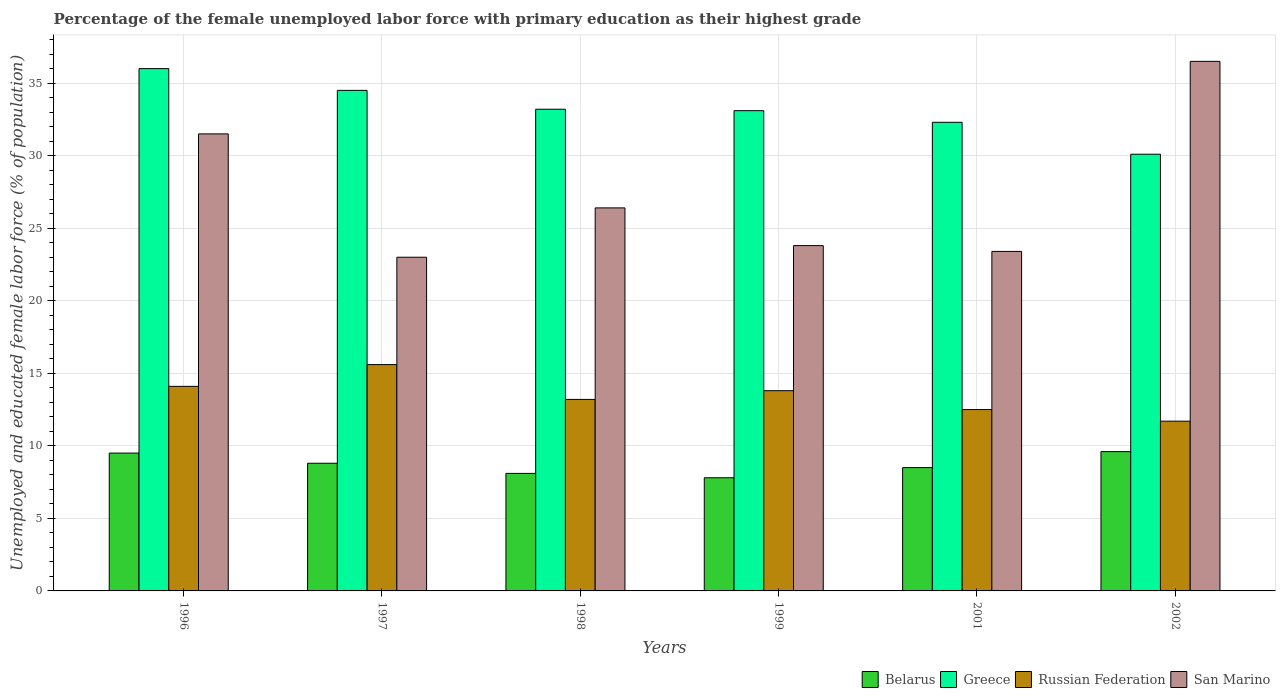How many different coloured bars are there?
Your response must be concise. 4. Are the number of bars per tick equal to the number of legend labels?
Make the answer very short. Yes. How many bars are there on the 3rd tick from the right?
Ensure brevity in your answer.  4. What is the label of the 5th group of bars from the left?
Offer a terse response. 2001. In how many cases, is the number of bars for a given year not equal to the number of legend labels?
Give a very brief answer. 0. What is the percentage of the unemployed female labor force with primary education in San Marino in 2002?
Make the answer very short. 36.5. Across all years, what is the maximum percentage of the unemployed female labor force with primary education in Belarus?
Provide a short and direct response. 9.6. Across all years, what is the minimum percentage of the unemployed female labor force with primary education in Belarus?
Keep it short and to the point. 7.8. In which year was the percentage of the unemployed female labor force with primary education in Greece minimum?
Make the answer very short. 2002. What is the total percentage of the unemployed female labor force with primary education in Russian Federation in the graph?
Your answer should be very brief. 80.9. What is the difference between the percentage of the unemployed female labor force with primary education in Greece in 1996 and that in 1998?
Your answer should be compact. 2.8. What is the difference between the percentage of the unemployed female labor force with primary education in Russian Federation in 2002 and the percentage of the unemployed female labor force with primary education in Belarus in 1996?
Offer a very short reply. 2.2. What is the average percentage of the unemployed female labor force with primary education in Russian Federation per year?
Give a very brief answer. 13.48. In the year 2002, what is the difference between the percentage of the unemployed female labor force with primary education in Russian Federation and percentage of the unemployed female labor force with primary education in Greece?
Provide a succinct answer. -18.4. What is the ratio of the percentage of the unemployed female labor force with primary education in Russian Federation in 1997 to that in 2002?
Your answer should be compact. 1.33. Is the percentage of the unemployed female labor force with primary education in Russian Federation in 1996 less than that in 1998?
Give a very brief answer. No. Is the difference between the percentage of the unemployed female labor force with primary education in Russian Federation in 1999 and 2001 greater than the difference between the percentage of the unemployed female labor force with primary education in Greece in 1999 and 2001?
Provide a short and direct response. Yes. What is the difference between the highest and the second highest percentage of the unemployed female labor force with primary education in Greece?
Make the answer very short. 1.5. What is the difference between the highest and the lowest percentage of the unemployed female labor force with primary education in San Marino?
Your response must be concise. 13.5. What does the 3rd bar from the left in 1999 represents?
Your answer should be compact. Russian Federation. What does the 1st bar from the right in 2002 represents?
Give a very brief answer. San Marino. Is it the case that in every year, the sum of the percentage of the unemployed female labor force with primary education in San Marino and percentage of the unemployed female labor force with primary education in Belarus is greater than the percentage of the unemployed female labor force with primary education in Greece?
Offer a very short reply. No. How many bars are there?
Your answer should be compact. 24. What is the difference between two consecutive major ticks on the Y-axis?
Your answer should be very brief. 5. Does the graph contain any zero values?
Offer a very short reply. No. Does the graph contain grids?
Keep it short and to the point. Yes. How many legend labels are there?
Offer a very short reply. 4. How are the legend labels stacked?
Your answer should be compact. Horizontal. What is the title of the graph?
Give a very brief answer. Percentage of the female unemployed labor force with primary education as their highest grade. What is the label or title of the X-axis?
Make the answer very short. Years. What is the label or title of the Y-axis?
Your answer should be compact. Unemployed and educated female labor force (% of population). What is the Unemployed and educated female labor force (% of population) in Russian Federation in 1996?
Give a very brief answer. 14.1. What is the Unemployed and educated female labor force (% of population) in San Marino in 1996?
Offer a terse response. 31.5. What is the Unemployed and educated female labor force (% of population) in Belarus in 1997?
Provide a succinct answer. 8.8. What is the Unemployed and educated female labor force (% of population) in Greece in 1997?
Your answer should be compact. 34.5. What is the Unemployed and educated female labor force (% of population) in Russian Federation in 1997?
Your response must be concise. 15.6. What is the Unemployed and educated female labor force (% of population) in Belarus in 1998?
Offer a terse response. 8.1. What is the Unemployed and educated female labor force (% of population) of Greece in 1998?
Offer a very short reply. 33.2. What is the Unemployed and educated female labor force (% of population) of Russian Federation in 1998?
Offer a very short reply. 13.2. What is the Unemployed and educated female labor force (% of population) in San Marino in 1998?
Ensure brevity in your answer.  26.4. What is the Unemployed and educated female labor force (% of population) of Belarus in 1999?
Offer a terse response. 7.8. What is the Unemployed and educated female labor force (% of population) in Greece in 1999?
Give a very brief answer. 33.1. What is the Unemployed and educated female labor force (% of population) in Russian Federation in 1999?
Your answer should be compact. 13.8. What is the Unemployed and educated female labor force (% of population) in San Marino in 1999?
Your answer should be compact. 23.8. What is the Unemployed and educated female labor force (% of population) in Greece in 2001?
Keep it short and to the point. 32.3. What is the Unemployed and educated female labor force (% of population) in San Marino in 2001?
Your answer should be very brief. 23.4. What is the Unemployed and educated female labor force (% of population) of Belarus in 2002?
Provide a succinct answer. 9.6. What is the Unemployed and educated female labor force (% of population) of Greece in 2002?
Make the answer very short. 30.1. What is the Unemployed and educated female labor force (% of population) in Russian Federation in 2002?
Keep it short and to the point. 11.7. What is the Unemployed and educated female labor force (% of population) in San Marino in 2002?
Your response must be concise. 36.5. Across all years, what is the maximum Unemployed and educated female labor force (% of population) of Belarus?
Keep it short and to the point. 9.6. Across all years, what is the maximum Unemployed and educated female labor force (% of population) in Greece?
Provide a short and direct response. 36. Across all years, what is the maximum Unemployed and educated female labor force (% of population) of Russian Federation?
Your answer should be compact. 15.6. Across all years, what is the maximum Unemployed and educated female labor force (% of population) in San Marino?
Offer a very short reply. 36.5. Across all years, what is the minimum Unemployed and educated female labor force (% of population) in Belarus?
Your response must be concise. 7.8. Across all years, what is the minimum Unemployed and educated female labor force (% of population) in Greece?
Provide a succinct answer. 30.1. Across all years, what is the minimum Unemployed and educated female labor force (% of population) of Russian Federation?
Make the answer very short. 11.7. What is the total Unemployed and educated female labor force (% of population) of Belarus in the graph?
Provide a short and direct response. 52.3. What is the total Unemployed and educated female labor force (% of population) of Greece in the graph?
Your answer should be compact. 199.2. What is the total Unemployed and educated female labor force (% of population) in Russian Federation in the graph?
Keep it short and to the point. 80.9. What is the total Unemployed and educated female labor force (% of population) in San Marino in the graph?
Provide a succinct answer. 164.6. What is the difference between the Unemployed and educated female labor force (% of population) in San Marino in 1996 and that in 1997?
Offer a very short reply. 8.5. What is the difference between the Unemployed and educated female labor force (% of population) in Belarus in 1996 and that in 1998?
Give a very brief answer. 1.4. What is the difference between the Unemployed and educated female labor force (% of population) in San Marino in 1996 and that in 1998?
Your answer should be compact. 5.1. What is the difference between the Unemployed and educated female labor force (% of population) of Belarus in 1996 and that in 1999?
Provide a succinct answer. 1.7. What is the difference between the Unemployed and educated female labor force (% of population) in Greece in 1996 and that in 2001?
Make the answer very short. 3.7. What is the difference between the Unemployed and educated female labor force (% of population) of Russian Federation in 1996 and that in 2002?
Ensure brevity in your answer.  2.4. What is the difference between the Unemployed and educated female labor force (% of population) in Belarus in 1997 and that in 1999?
Make the answer very short. 1. What is the difference between the Unemployed and educated female labor force (% of population) of Russian Federation in 1997 and that in 1999?
Keep it short and to the point. 1.8. What is the difference between the Unemployed and educated female labor force (% of population) of San Marino in 1997 and that in 1999?
Keep it short and to the point. -0.8. What is the difference between the Unemployed and educated female labor force (% of population) of San Marino in 1997 and that in 2001?
Keep it short and to the point. -0.4. What is the difference between the Unemployed and educated female labor force (% of population) in Greece in 1997 and that in 2002?
Provide a succinct answer. 4.4. What is the difference between the Unemployed and educated female labor force (% of population) in Greece in 1998 and that in 1999?
Your answer should be compact. 0.1. What is the difference between the Unemployed and educated female labor force (% of population) in Russian Federation in 1998 and that in 1999?
Make the answer very short. -0.6. What is the difference between the Unemployed and educated female labor force (% of population) of San Marino in 1998 and that in 1999?
Keep it short and to the point. 2.6. What is the difference between the Unemployed and educated female labor force (% of population) in Russian Federation in 1998 and that in 2001?
Provide a succinct answer. 0.7. What is the difference between the Unemployed and educated female labor force (% of population) of San Marino in 1998 and that in 2002?
Make the answer very short. -10.1. What is the difference between the Unemployed and educated female labor force (% of population) of Greece in 1999 and that in 2001?
Provide a short and direct response. 0.8. What is the difference between the Unemployed and educated female labor force (% of population) of Russian Federation in 1999 and that in 2001?
Offer a terse response. 1.3. What is the difference between the Unemployed and educated female labor force (% of population) of San Marino in 1999 and that in 2001?
Offer a terse response. 0.4. What is the difference between the Unemployed and educated female labor force (% of population) in Greece in 1999 and that in 2002?
Give a very brief answer. 3. What is the difference between the Unemployed and educated female labor force (% of population) of Belarus in 2001 and that in 2002?
Your answer should be very brief. -1.1. What is the difference between the Unemployed and educated female labor force (% of population) in Greece in 2001 and that in 2002?
Provide a succinct answer. 2.2. What is the difference between the Unemployed and educated female labor force (% of population) in Belarus in 1996 and the Unemployed and educated female labor force (% of population) in Greece in 1997?
Keep it short and to the point. -25. What is the difference between the Unemployed and educated female labor force (% of population) of Belarus in 1996 and the Unemployed and educated female labor force (% of population) of Russian Federation in 1997?
Your response must be concise. -6.1. What is the difference between the Unemployed and educated female labor force (% of population) of Belarus in 1996 and the Unemployed and educated female labor force (% of population) of San Marino in 1997?
Make the answer very short. -13.5. What is the difference between the Unemployed and educated female labor force (% of population) of Greece in 1996 and the Unemployed and educated female labor force (% of population) of Russian Federation in 1997?
Provide a succinct answer. 20.4. What is the difference between the Unemployed and educated female labor force (% of population) of Belarus in 1996 and the Unemployed and educated female labor force (% of population) of Greece in 1998?
Ensure brevity in your answer.  -23.7. What is the difference between the Unemployed and educated female labor force (% of population) of Belarus in 1996 and the Unemployed and educated female labor force (% of population) of San Marino in 1998?
Provide a short and direct response. -16.9. What is the difference between the Unemployed and educated female labor force (% of population) in Greece in 1996 and the Unemployed and educated female labor force (% of population) in Russian Federation in 1998?
Your response must be concise. 22.8. What is the difference between the Unemployed and educated female labor force (% of population) in Greece in 1996 and the Unemployed and educated female labor force (% of population) in San Marino in 1998?
Offer a terse response. 9.6. What is the difference between the Unemployed and educated female labor force (% of population) of Belarus in 1996 and the Unemployed and educated female labor force (% of population) of Greece in 1999?
Your answer should be compact. -23.6. What is the difference between the Unemployed and educated female labor force (% of population) of Belarus in 1996 and the Unemployed and educated female labor force (% of population) of Russian Federation in 1999?
Keep it short and to the point. -4.3. What is the difference between the Unemployed and educated female labor force (% of population) of Belarus in 1996 and the Unemployed and educated female labor force (% of population) of San Marino in 1999?
Your answer should be very brief. -14.3. What is the difference between the Unemployed and educated female labor force (% of population) of Greece in 1996 and the Unemployed and educated female labor force (% of population) of Russian Federation in 1999?
Your answer should be very brief. 22.2. What is the difference between the Unemployed and educated female labor force (% of population) of Greece in 1996 and the Unemployed and educated female labor force (% of population) of San Marino in 1999?
Ensure brevity in your answer.  12.2. What is the difference between the Unemployed and educated female labor force (% of population) in Russian Federation in 1996 and the Unemployed and educated female labor force (% of population) in San Marino in 1999?
Offer a terse response. -9.7. What is the difference between the Unemployed and educated female labor force (% of population) of Belarus in 1996 and the Unemployed and educated female labor force (% of population) of Greece in 2001?
Your answer should be very brief. -22.8. What is the difference between the Unemployed and educated female labor force (% of population) of Belarus in 1996 and the Unemployed and educated female labor force (% of population) of San Marino in 2001?
Your answer should be very brief. -13.9. What is the difference between the Unemployed and educated female labor force (% of population) of Greece in 1996 and the Unemployed and educated female labor force (% of population) of Russian Federation in 2001?
Offer a very short reply. 23.5. What is the difference between the Unemployed and educated female labor force (% of population) of Belarus in 1996 and the Unemployed and educated female labor force (% of population) of Greece in 2002?
Your response must be concise. -20.6. What is the difference between the Unemployed and educated female labor force (% of population) of Belarus in 1996 and the Unemployed and educated female labor force (% of population) of Russian Federation in 2002?
Keep it short and to the point. -2.2. What is the difference between the Unemployed and educated female labor force (% of population) in Belarus in 1996 and the Unemployed and educated female labor force (% of population) in San Marino in 2002?
Make the answer very short. -27. What is the difference between the Unemployed and educated female labor force (% of population) of Greece in 1996 and the Unemployed and educated female labor force (% of population) of Russian Federation in 2002?
Provide a short and direct response. 24.3. What is the difference between the Unemployed and educated female labor force (% of population) of Greece in 1996 and the Unemployed and educated female labor force (% of population) of San Marino in 2002?
Offer a terse response. -0.5. What is the difference between the Unemployed and educated female labor force (% of population) of Russian Federation in 1996 and the Unemployed and educated female labor force (% of population) of San Marino in 2002?
Your answer should be very brief. -22.4. What is the difference between the Unemployed and educated female labor force (% of population) in Belarus in 1997 and the Unemployed and educated female labor force (% of population) in Greece in 1998?
Your response must be concise. -24.4. What is the difference between the Unemployed and educated female labor force (% of population) in Belarus in 1997 and the Unemployed and educated female labor force (% of population) in Russian Federation in 1998?
Your answer should be compact. -4.4. What is the difference between the Unemployed and educated female labor force (% of population) of Belarus in 1997 and the Unemployed and educated female labor force (% of population) of San Marino in 1998?
Keep it short and to the point. -17.6. What is the difference between the Unemployed and educated female labor force (% of population) in Greece in 1997 and the Unemployed and educated female labor force (% of population) in Russian Federation in 1998?
Make the answer very short. 21.3. What is the difference between the Unemployed and educated female labor force (% of population) of Russian Federation in 1997 and the Unemployed and educated female labor force (% of population) of San Marino in 1998?
Give a very brief answer. -10.8. What is the difference between the Unemployed and educated female labor force (% of population) of Belarus in 1997 and the Unemployed and educated female labor force (% of population) of Greece in 1999?
Offer a very short reply. -24.3. What is the difference between the Unemployed and educated female labor force (% of population) of Belarus in 1997 and the Unemployed and educated female labor force (% of population) of Russian Federation in 1999?
Make the answer very short. -5. What is the difference between the Unemployed and educated female labor force (% of population) of Belarus in 1997 and the Unemployed and educated female labor force (% of population) of San Marino in 1999?
Your answer should be very brief. -15. What is the difference between the Unemployed and educated female labor force (% of population) of Greece in 1997 and the Unemployed and educated female labor force (% of population) of Russian Federation in 1999?
Provide a succinct answer. 20.7. What is the difference between the Unemployed and educated female labor force (% of population) of Belarus in 1997 and the Unemployed and educated female labor force (% of population) of Greece in 2001?
Provide a succinct answer. -23.5. What is the difference between the Unemployed and educated female labor force (% of population) in Belarus in 1997 and the Unemployed and educated female labor force (% of population) in San Marino in 2001?
Provide a short and direct response. -14.6. What is the difference between the Unemployed and educated female labor force (% of population) in Greece in 1997 and the Unemployed and educated female labor force (% of population) in Russian Federation in 2001?
Give a very brief answer. 22. What is the difference between the Unemployed and educated female labor force (% of population) in Greece in 1997 and the Unemployed and educated female labor force (% of population) in San Marino in 2001?
Offer a very short reply. 11.1. What is the difference between the Unemployed and educated female labor force (% of population) in Russian Federation in 1997 and the Unemployed and educated female labor force (% of population) in San Marino in 2001?
Make the answer very short. -7.8. What is the difference between the Unemployed and educated female labor force (% of population) in Belarus in 1997 and the Unemployed and educated female labor force (% of population) in Greece in 2002?
Your answer should be compact. -21.3. What is the difference between the Unemployed and educated female labor force (% of population) in Belarus in 1997 and the Unemployed and educated female labor force (% of population) in San Marino in 2002?
Offer a very short reply. -27.7. What is the difference between the Unemployed and educated female labor force (% of population) of Greece in 1997 and the Unemployed and educated female labor force (% of population) of Russian Federation in 2002?
Your answer should be compact. 22.8. What is the difference between the Unemployed and educated female labor force (% of population) of Greece in 1997 and the Unemployed and educated female labor force (% of population) of San Marino in 2002?
Offer a very short reply. -2. What is the difference between the Unemployed and educated female labor force (% of population) of Russian Federation in 1997 and the Unemployed and educated female labor force (% of population) of San Marino in 2002?
Your response must be concise. -20.9. What is the difference between the Unemployed and educated female labor force (% of population) of Belarus in 1998 and the Unemployed and educated female labor force (% of population) of Greece in 1999?
Keep it short and to the point. -25. What is the difference between the Unemployed and educated female labor force (% of population) of Belarus in 1998 and the Unemployed and educated female labor force (% of population) of Russian Federation in 1999?
Offer a very short reply. -5.7. What is the difference between the Unemployed and educated female labor force (% of population) in Belarus in 1998 and the Unemployed and educated female labor force (% of population) in San Marino in 1999?
Offer a terse response. -15.7. What is the difference between the Unemployed and educated female labor force (% of population) in Greece in 1998 and the Unemployed and educated female labor force (% of population) in Russian Federation in 1999?
Your answer should be compact. 19.4. What is the difference between the Unemployed and educated female labor force (% of population) in Greece in 1998 and the Unemployed and educated female labor force (% of population) in San Marino in 1999?
Provide a succinct answer. 9.4. What is the difference between the Unemployed and educated female labor force (% of population) in Belarus in 1998 and the Unemployed and educated female labor force (% of population) in Greece in 2001?
Keep it short and to the point. -24.2. What is the difference between the Unemployed and educated female labor force (% of population) of Belarus in 1998 and the Unemployed and educated female labor force (% of population) of Russian Federation in 2001?
Offer a very short reply. -4.4. What is the difference between the Unemployed and educated female labor force (% of population) of Belarus in 1998 and the Unemployed and educated female labor force (% of population) of San Marino in 2001?
Offer a terse response. -15.3. What is the difference between the Unemployed and educated female labor force (% of population) in Greece in 1998 and the Unemployed and educated female labor force (% of population) in Russian Federation in 2001?
Make the answer very short. 20.7. What is the difference between the Unemployed and educated female labor force (% of population) of Greece in 1998 and the Unemployed and educated female labor force (% of population) of San Marino in 2001?
Your response must be concise. 9.8. What is the difference between the Unemployed and educated female labor force (% of population) of Belarus in 1998 and the Unemployed and educated female labor force (% of population) of Russian Federation in 2002?
Offer a very short reply. -3.6. What is the difference between the Unemployed and educated female labor force (% of population) in Belarus in 1998 and the Unemployed and educated female labor force (% of population) in San Marino in 2002?
Your answer should be very brief. -28.4. What is the difference between the Unemployed and educated female labor force (% of population) in Russian Federation in 1998 and the Unemployed and educated female labor force (% of population) in San Marino in 2002?
Make the answer very short. -23.3. What is the difference between the Unemployed and educated female labor force (% of population) in Belarus in 1999 and the Unemployed and educated female labor force (% of population) in Greece in 2001?
Your answer should be very brief. -24.5. What is the difference between the Unemployed and educated female labor force (% of population) in Belarus in 1999 and the Unemployed and educated female labor force (% of population) in Russian Federation in 2001?
Offer a terse response. -4.7. What is the difference between the Unemployed and educated female labor force (% of population) in Belarus in 1999 and the Unemployed and educated female labor force (% of population) in San Marino in 2001?
Offer a terse response. -15.6. What is the difference between the Unemployed and educated female labor force (% of population) in Greece in 1999 and the Unemployed and educated female labor force (% of population) in Russian Federation in 2001?
Your answer should be very brief. 20.6. What is the difference between the Unemployed and educated female labor force (% of population) of Greece in 1999 and the Unemployed and educated female labor force (% of population) of San Marino in 2001?
Make the answer very short. 9.7. What is the difference between the Unemployed and educated female labor force (% of population) in Russian Federation in 1999 and the Unemployed and educated female labor force (% of population) in San Marino in 2001?
Your answer should be very brief. -9.6. What is the difference between the Unemployed and educated female labor force (% of population) in Belarus in 1999 and the Unemployed and educated female labor force (% of population) in Greece in 2002?
Provide a short and direct response. -22.3. What is the difference between the Unemployed and educated female labor force (% of population) of Belarus in 1999 and the Unemployed and educated female labor force (% of population) of San Marino in 2002?
Your answer should be very brief. -28.7. What is the difference between the Unemployed and educated female labor force (% of population) of Greece in 1999 and the Unemployed and educated female labor force (% of population) of Russian Federation in 2002?
Provide a succinct answer. 21.4. What is the difference between the Unemployed and educated female labor force (% of population) of Russian Federation in 1999 and the Unemployed and educated female labor force (% of population) of San Marino in 2002?
Give a very brief answer. -22.7. What is the difference between the Unemployed and educated female labor force (% of population) in Belarus in 2001 and the Unemployed and educated female labor force (% of population) in Greece in 2002?
Your response must be concise. -21.6. What is the difference between the Unemployed and educated female labor force (% of population) of Belarus in 2001 and the Unemployed and educated female labor force (% of population) of Russian Federation in 2002?
Make the answer very short. -3.2. What is the difference between the Unemployed and educated female labor force (% of population) of Greece in 2001 and the Unemployed and educated female labor force (% of population) of Russian Federation in 2002?
Ensure brevity in your answer.  20.6. What is the difference between the Unemployed and educated female labor force (% of population) of Russian Federation in 2001 and the Unemployed and educated female labor force (% of population) of San Marino in 2002?
Keep it short and to the point. -24. What is the average Unemployed and educated female labor force (% of population) in Belarus per year?
Offer a terse response. 8.72. What is the average Unemployed and educated female labor force (% of population) in Greece per year?
Make the answer very short. 33.2. What is the average Unemployed and educated female labor force (% of population) in Russian Federation per year?
Keep it short and to the point. 13.48. What is the average Unemployed and educated female labor force (% of population) in San Marino per year?
Your answer should be very brief. 27.43. In the year 1996, what is the difference between the Unemployed and educated female labor force (% of population) of Belarus and Unemployed and educated female labor force (% of population) of Greece?
Your answer should be compact. -26.5. In the year 1996, what is the difference between the Unemployed and educated female labor force (% of population) of Greece and Unemployed and educated female labor force (% of population) of Russian Federation?
Offer a terse response. 21.9. In the year 1996, what is the difference between the Unemployed and educated female labor force (% of population) of Russian Federation and Unemployed and educated female labor force (% of population) of San Marino?
Keep it short and to the point. -17.4. In the year 1997, what is the difference between the Unemployed and educated female labor force (% of population) in Belarus and Unemployed and educated female labor force (% of population) in Greece?
Keep it short and to the point. -25.7. In the year 1997, what is the difference between the Unemployed and educated female labor force (% of population) of Belarus and Unemployed and educated female labor force (% of population) of San Marino?
Your response must be concise. -14.2. In the year 1997, what is the difference between the Unemployed and educated female labor force (% of population) of Greece and Unemployed and educated female labor force (% of population) of Russian Federation?
Keep it short and to the point. 18.9. In the year 1997, what is the difference between the Unemployed and educated female labor force (% of population) in Greece and Unemployed and educated female labor force (% of population) in San Marino?
Provide a succinct answer. 11.5. In the year 1998, what is the difference between the Unemployed and educated female labor force (% of population) of Belarus and Unemployed and educated female labor force (% of population) of Greece?
Keep it short and to the point. -25.1. In the year 1998, what is the difference between the Unemployed and educated female labor force (% of population) of Belarus and Unemployed and educated female labor force (% of population) of San Marino?
Your answer should be compact. -18.3. In the year 1998, what is the difference between the Unemployed and educated female labor force (% of population) of Greece and Unemployed and educated female labor force (% of population) of Russian Federation?
Your response must be concise. 20. In the year 1998, what is the difference between the Unemployed and educated female labor force (% of population) of Greece and Unemployed and educated female labor force (% of population) of San Marino?
Give a very brief answer. 6.8. In the year 1999, what is the difference between the Unemployed and educated female labor force (% of population) of Belarus and Unemployed and educated female labor force (% of population) of Greece?
Your answer should be very brief. -25.3. In the year 1999, what is the difference between the Unemployed and educated female labor force (% of population) in Belarus and Unemployed and educated female labor force (% of population) in Russian Federation?
Keep it short and to the point. -6. In the year 1999, what is the difference between the Unemployed and educated female labor force (% of population) in Greece and Unemployed and educated female labor force (% of population) in Russian Federation?
Offer a very short reply. 19.3. In the year 1999, what is the difference between the Unemployed and educated female labor force (% of population) of Russian Federation and Unemployed and educated female labor force (% of population) of San Marino?
Ensure brevity in your answer.  -10. In the year 2001, what is the difference between the Unemployed and educated female labor force (% of population) in Belarus and Unemployed and educated female labor force (% of population) in Greece?
Your answer should be very brief. -23.8. In the year 2001, what is the difference between the Unemployed and educated female labor force (% of population) of Belarus and Unemployed and educated female labor force (% of population) of San Marino?
Offer a very short reply. -14.9. In the year 2001, what is the difference between the Unemployed and educated female labor force (% of population) in Greece and Unemployed and educated female labor force (% of population) in Russian Federation?
Your response must be concise. 19.8. In the year 2001, what is the difference between the Unemployed and educated female labor force (% of population) in Greece and Unemployed and educated female labor force (% of population) in San Marino?
Make the answer very short. 8.9. In the year 2001, what is the difference between the Unemployed and educated female labor force (% of population) of Russian Federation and Unemployed and educated female labor force (% of population) of San Marino?
Your answer should be compact. -10.9. In the year 2002, what is the difference between the Unemployed and educated female labor force (% of population) of Belarus and Unemployed and educated female labor force (% of population) of Greece?
Keep it short and to the point. -20.5. In the year 2002, what is the difference between the Unemployed and educated female labor force (% of population) of Belarus and Unemployed and educated female labor force (% of population) of Russian Federation?
Your answer should be compact. -2.1. In the year 2002, what is the difference between the Unemployed and educated female labor force (% of population) in Belarus and Unemployed and educated female labor force (% of population) in San Marino?
Make the answer very short. -26.9. In the year 2002, what is the difference between the Unemployed and educated female labor force (% of population) in Greece and Unemployed and educated female labor force (% of population) in Russian Federation?
Provide a succinct answer. 18.4. In the year 2002, what is the difference between the Unemployed and educated female labor force (% of population) in Russian Federation and Unemployed and educated female labor force (% of population) in San Marino?
Give a very brief answer. -24.8. What is the ratio of the Unemployed and educated female labor force (% of population) of Belarus in 1996 to that in 1997?
Ensure brevity in your answer.  1.08. What is the ratio of the Unemployed and educated female labor force (% of population) of Greece in 1996 to that in 1997?
Offer a very short reply. 1.04. What is the ratio of the Unemployed and educated female labor force (% of population) in Russian Federation in 1996 to that in 1997?
Offer a very short reply. 0.9. What is the ratio of the Unemployed and educated female labor force (% of population) in San Marino in 1996 to that in 1997?
Keep it short and to the point. 1.37. What is the ratio of the Unemployed and educated female labor force (% of population) of Belarus in 1996 to that in 1998?
Offer a very short reply. 1.17. What is the ratio of the Unemployed and educated female labor force (% of population) in Greece in 1996 to that in 1998?
Your answer should be compact. 1.08. What is the ratio of the Unemployed and educated female labor force (% of population) in Russian Federation in 1996 to that in 1998?
Ensure brevity in your answer.  1.07. What is the ratio of the Unemployed and educated female labor force (% of population) in San Marino in 1996 to that in 1998?
Ensure brevity in your answer.  1.19. What is the ratio of the Unemployed and educated female labor force (% of population) of Belarus in 1996 to that in 1999?
Your response must be concise. 1.22. What is the ratio of the Unemployed and educated female labor force (% of population) of Greece in 1996 to that in 1999?
Your answer should be very brief. 1.09. What is the ratio of the Unemployed and educated female labor force (% of population) in Russian Federation in 1996 to that in 1999?
Provide a succinct answer. 1.02. What is the ratio of the Unemployed and educated female labor force (% of population) in San Marino in 1996 to that in 1999?
Your answer should be very brief. 1.32. What is the ratio of the Unemployed and educated female labor force (% of population) of Belarus in 1996 to that in 2001?
Ensure brevity in your answer.  1.12. What is the ratio of the Unemployed and educated female labor force (% of population) of Greece in 1996 to that in 2001?
Provide a short and direct response. 1.11. What is the ratio of the Unemployed and educated female labor force (% of population) of Russian Federation in 1996 to that in 2001?
Offer a very short reply. 1.13. What is the ratio of the Unemployed and educated female labor force (% of population) of San Marino in 1996 to that in 2001?
Provide a succinct answer. 1.35. What is the ratio of the Unemployed and educated female labor force (% of population) of Belarus in 1996 to that in 2002?
Offer a terse response. 0.99. What is the ratio of the Unemployed and educated female labor force (% of population) of Greece in 1996 to that in 2002?
Provide a short and direct response. 1.2. What is the ratio of the Unemployed and educated female labor force (% of population) of Russian Federation in 1996 to that in 2002?
Your response must be concise. 1.21. What is the ratio of the Unemployed and educated female labor force (% of population) of San Marino in 1996 to that in 2002?
Offer a terse response. 0.86. What is the ratio of the Unemployed and educated female labor force (% of population) of Belarus in 1997 to that in 1998?
Give a very brief answer. 1.09. What is the ratio of the Unemployed and educated female labor force (% of population) of Greece in 1997 to that in 1998?
Make the answer very short. 1.04. What is the ratio of the Unemployed and educated female labor force (% of population) of Russian Federation in 1997 to that in 1998?
Make the answer very short. 1.18. What is the ratio of the Unemployed and educated female labor force (% of population) of San Marino in 1997 to that in 1998?
Make the answer very short. 0.87. What is the ratio of the Unemployed and educated female labor force (% of population) in Belarus in 1997 to that in 1999?
Provide a short and direct response. 1.13. What is the ratio of the Unemployed and educated female labor force (% of population) of Greece in 1997 to that in 1999?
Your response must be concise. 1.04. What is the ratio of the Unemployed and educated female labor force (% of population) of Russian Federation in 1997 to that in 1999?
Your response must be concise. 1.13. What is the ratio of the Unemployed and educated female labor force (% of population) of San Marino in 1997 to that in 1999?
Make the answer very short. 0.97. What is the ratio of the Unemployed and educated female labor force (% of population) in Belarus in 1997 to that in 2001?
Your answer should be compact. 1.04. What is the ratio of the Unemployed and educated female labor force (% of population) in Greece in 1997 to that in 2001?
Your response must be concise. 1.07. What is the ratio of the Unemployed and educated female labor force (% of population) in Russian Federation in 1997 to that in 2001?
Provide a succinct answer. 1.25. What is the ratio of the Unemployed and educated female labor force (% of population) in San Marino in 1997 to that in 2001?
Provide a short and direct response. 0.98. What is the ratio of the Unemployed and educated female labor force (% of population) in Greece in 1997 to that in 2002?
Your answer should be very brief. 1.15. What is the ratio of the Unemployed and educated female labor force (% of population) in Russian Federation in 1997 to that in 2002?
Ensure brevity in your answer.  1.33. What is the ratio of the Unemployed and educated female labor force (% of population) of San Marino in 1997 to that in 2002?
Provide a short and direct response. 0.63. What is the ratio of the Unemployed and educated female labor force (% of population) in Belarus in 1998 to that in 1999?
Provide a succinct answer. 1.04. What is the ratio of the Unemployed and educated female labor force (% of population) of Russian Federation in 1998 to that in 1999?
Your response must be concise. 0.96. What is the ratio of the Unemployed and educated female labor force (% of population) in San Marino in 1998 to that in 1999?
Your answer should be very brief. 1.11. What is the ratio of the Unemployed and educated female labor force (% of population) in Belarus in 1998 to that in 2001?
Ensure brevity in your answer.  0.95. What is the ratio of the Unemployed and educated female labor force (% of population) of Greece in 1998 to that in 2001?
Offer a terse response. 1.03. What is the ratio of the Unemployed and educated female labor force (% of population) in Russian Federation in 1998 to that in 2001?
Provide a succinct answer. 1.06. What is the ratio of the Unemployed and educated female labor force (% of population) of San Marino in 1998 to that in 2001?
Keep it short and to the point. 1.13. What is the ratio of the Unemployed and educated female labor force (% of population) in Belarus in 1998 to that in 2002?
Make the answer very short. 0.84. What is the ratio of the Unemployed and educated female labor force (% of population) of Greece in 1998 to that in 2002?
Provide a short and direct response. 1.1. What is the ratio of the Unemployed and educated female labor force (% of population) of Russian Federation in 1998 to that in 2002?
Offer a terse response. 1.13. What is the ratio of the Unemployed and educated female labor force (% of population) of San Marino in 1998 to that in 2002?
Ensure brevity in your answer.  0.72. What is the ratio of the Unemployed and educated female labor force (% of population) in Belarus in 1999 to that in 2001?
Provide a short and direct response. 0.92. What is the ratio of the Unemployed and educated female labor force (% of population) of Greece in 1999 to that in 2001?
Provide a short and direct response. 1.02. What is the ratio of the Unemployed and educated female labor force (% of population) in Russian Federation in 1999 to that in 2001?
Offer a very short reply. 1.1. What is the ratio of the Unemployed and educated female labor force (% of population) in San Marino in 1999 to that in 2001?
Give a very brief answer. 1.02. What is the ratio of the Unemployed and educated female labor force (% of population) in Belarus in 1999 to that in 2002?
Ensure brevity in your answer.  0.81. What is the ratio of the Unemployed and educated female labor force (% of population) in Greece in 1999 to that in 2002?
Provide a succinct answer. 1.1. What is the ratio of the Unemployed and educated female labor force (% of population) of Russian Federation in 1999 to that in 2002?
Make the answer very short. 1.18. What is the ratio of the Unemployed and educated female labor force (% of population) in San Marino in 1999 to that in 2002?
Offer a terse response. 0.65. What is the ratio of the Unemployed and educated female labor force (% of population) of Belarus in 2001 to that in 2002?
Offer a very short reply. 0.89. What is the ratio of the Unemployed and educated female labor force (% of population) in Greece in 2001 to that in 2002?
Offer a very short reply. 1.07. What is the ratio of the Unemployed and educated female labor force (% of population) in Russian Federation in 2001 to that in 2002?
Your answer should be compact. 1.07. What is the ratio of the Unemployed and educated female labor force (% of population) in San Marino in 2001 to that in 2002?
Offer a very short reply. 0.64. What is the difference between the highest and the second highest Unemployed and educated female labor force (% of population) of San Marino?
Offer a very short reply. 5. What is the difference between the highest and the lowest Unemployed and educated female labor force (% of population) in San Marino?
Your answer should be compact. 13.5. 